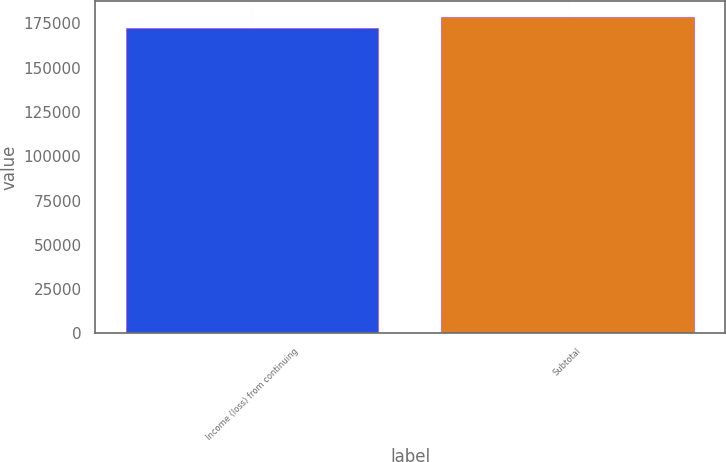Convert chart. <chart><loc_0><loc_0><loc_500><loc_500><bar_chart><fcel>Income (loss) from continuing<fcel>Subtotal<nl><fcel>172270<fcel>178798<nl></chart> 